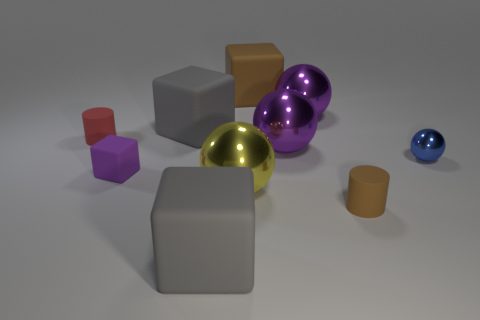How big is the blue metallic object?
Your answer should be compact. Small. Does the small shiny object have the same color as the shiny object that is in front of the tiny purple rubber thing?
Keep it short and to the point. No. There is a small cylinder that is right of the brown cube that is behind the yellow ball; what color is it?
Offer a terse response. Brown. Is there any other thing that has the same size as the purple matte cube?
Your answer should be compact. Yes. Is the shape of the gray thing in front of the blue sphere the same as  the big yellow metallic thing?
Offer a very short reply. No. How many gray matte objects are in front of the small brown thing and behind the small red rubber object?
Provide a short and direct response. 0. There is a matte cylinder right of the red matte cylinder that is to the left of the metal sphere in front of the small purple cube; what color is it?
Provide a short and direct response. Brown. There is a blue thing to the right of the big brown object; what number of blue things are right of it?
Your response must be concise. 0. How many other things are there of the same shape as the tiny blue object?
Your answer should be compact. 3. How many objects are either small green shiny cubes or tiny things that are on the right side of the large brown matte cube?
Your answer should be very brief. 2. 